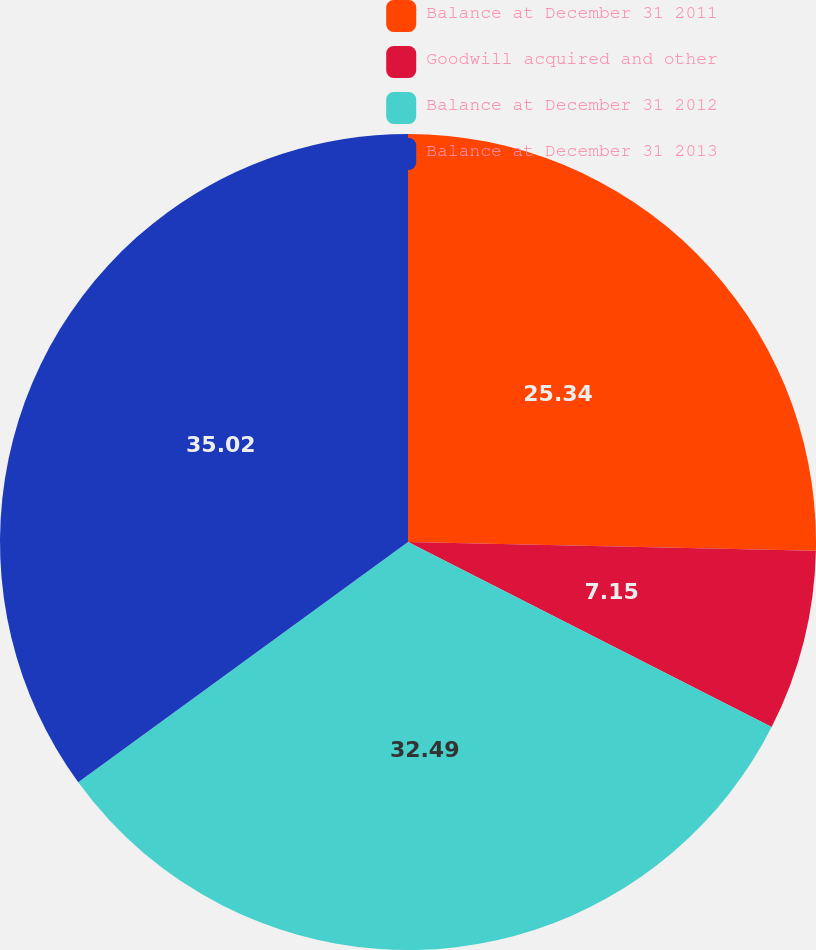Convert chart. <chart><loc_0><loc_0><loc_500><loc_500><pie_chart><fcel>Balance at December 31 2011<fcel>Goodwill acquired and other<fcel>Balance at December 31 2012<fcel>Balance at December 31 2013<nl><fcel>25.34%<fcel>7.15%<fcel>32.49%<fcel>35.02%<nl></chart> 